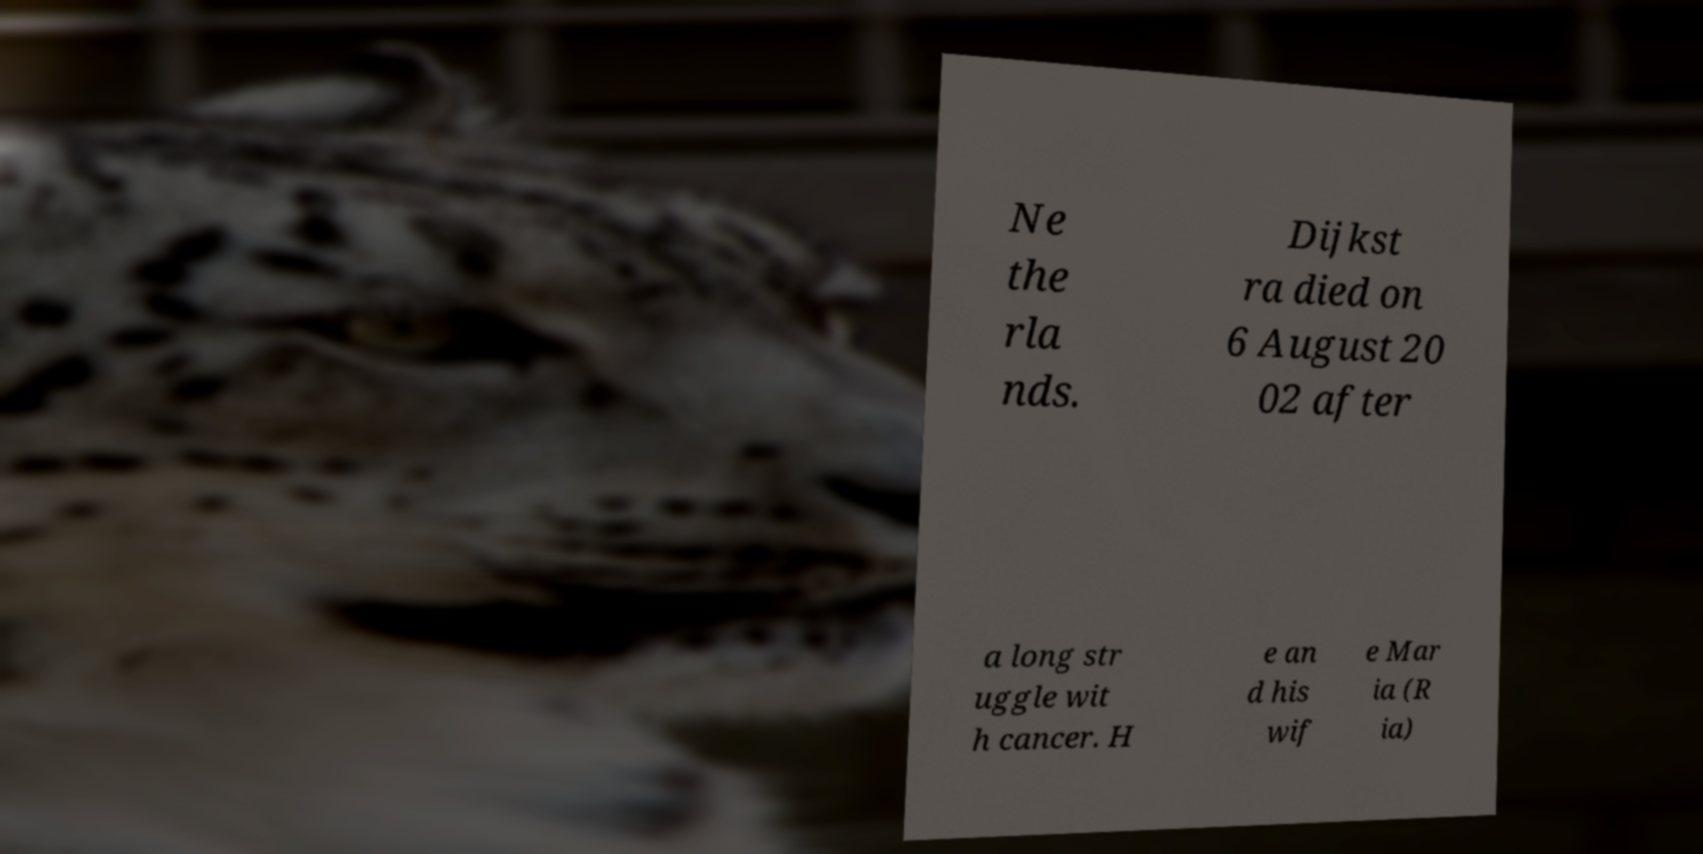Could you extract and type out the text from this image? Ne the rla nds. Dijkst ra died on 6 August 20 02 after a long str uggle wit h cancer. H e an d his wif e Mar ia (R ia) 